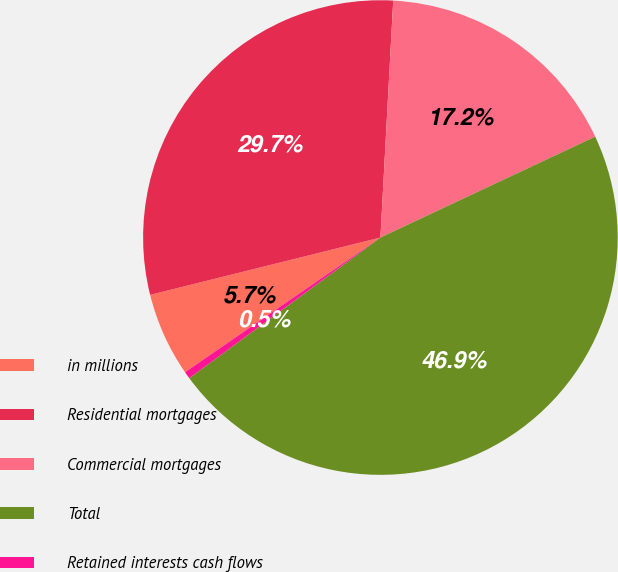<chart> <loc_0><loc_0><loc_500><loc_500><pie_chart><fcel>in millions<fcel>Residential mortgages<fcel>Commercial mortgages<fcel>Total<fcel>Retained interests cash flows<nl><fcel>5.72%<fcel>29.74%<fcel>17.15%<fcel>46.89%<fcel>0.49%<nl></chart> 